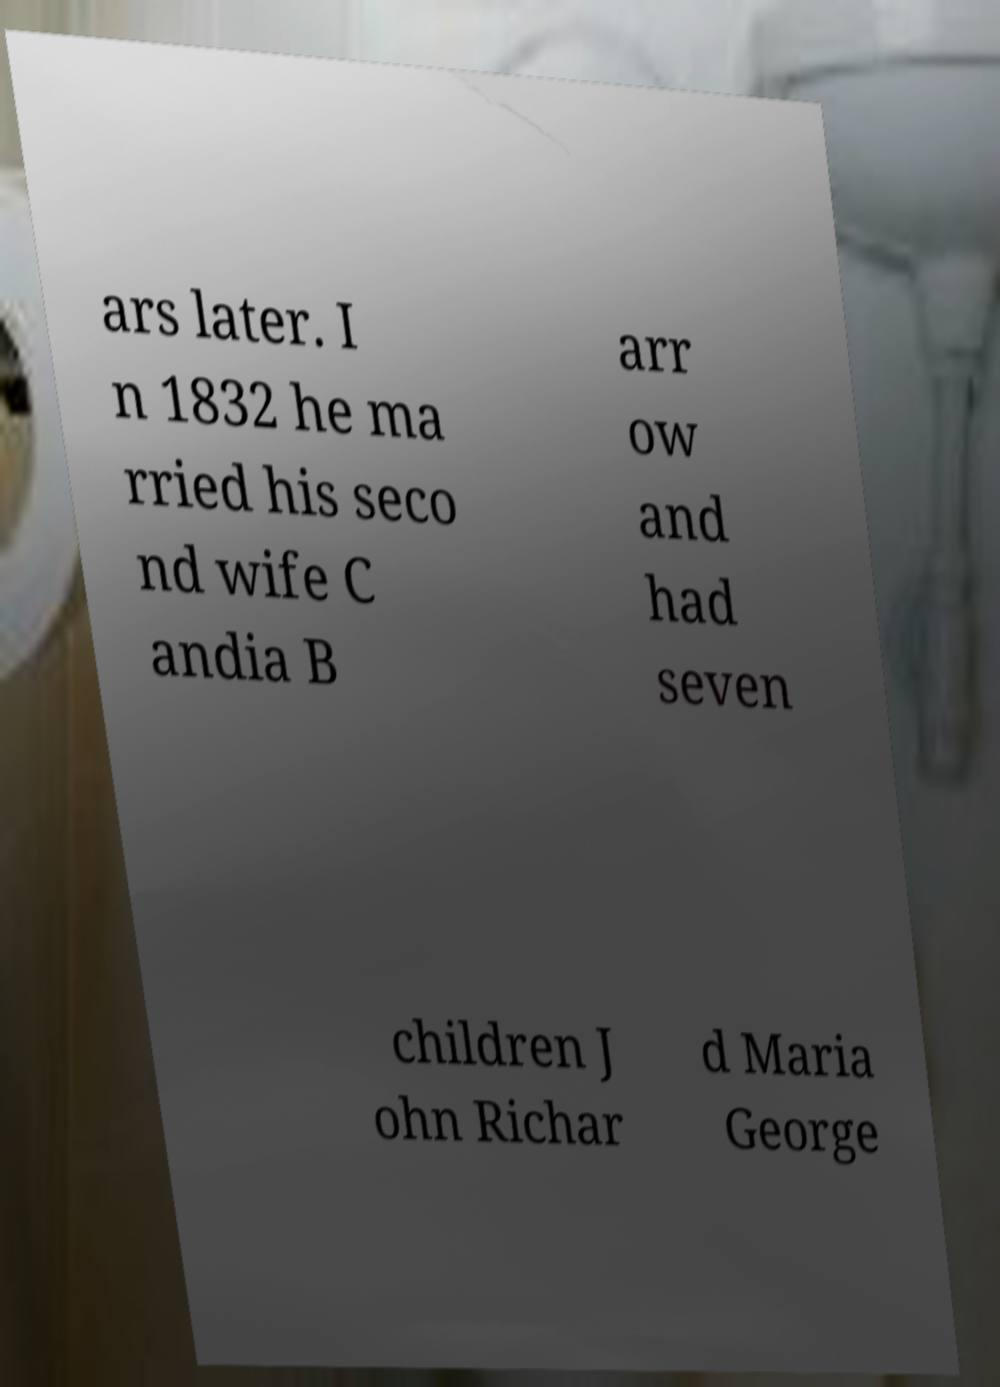Please identify and transcribe the text found in this image. ars later. I n 1832 he ma rried his seco nd wife C andia B arr ow and had seven children J ohn Richar d Maria George 